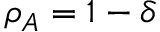<formula> <loc_0><loc_0><loc_500><loc_500>\rho _ { A } = 1 - \delta</formula> 